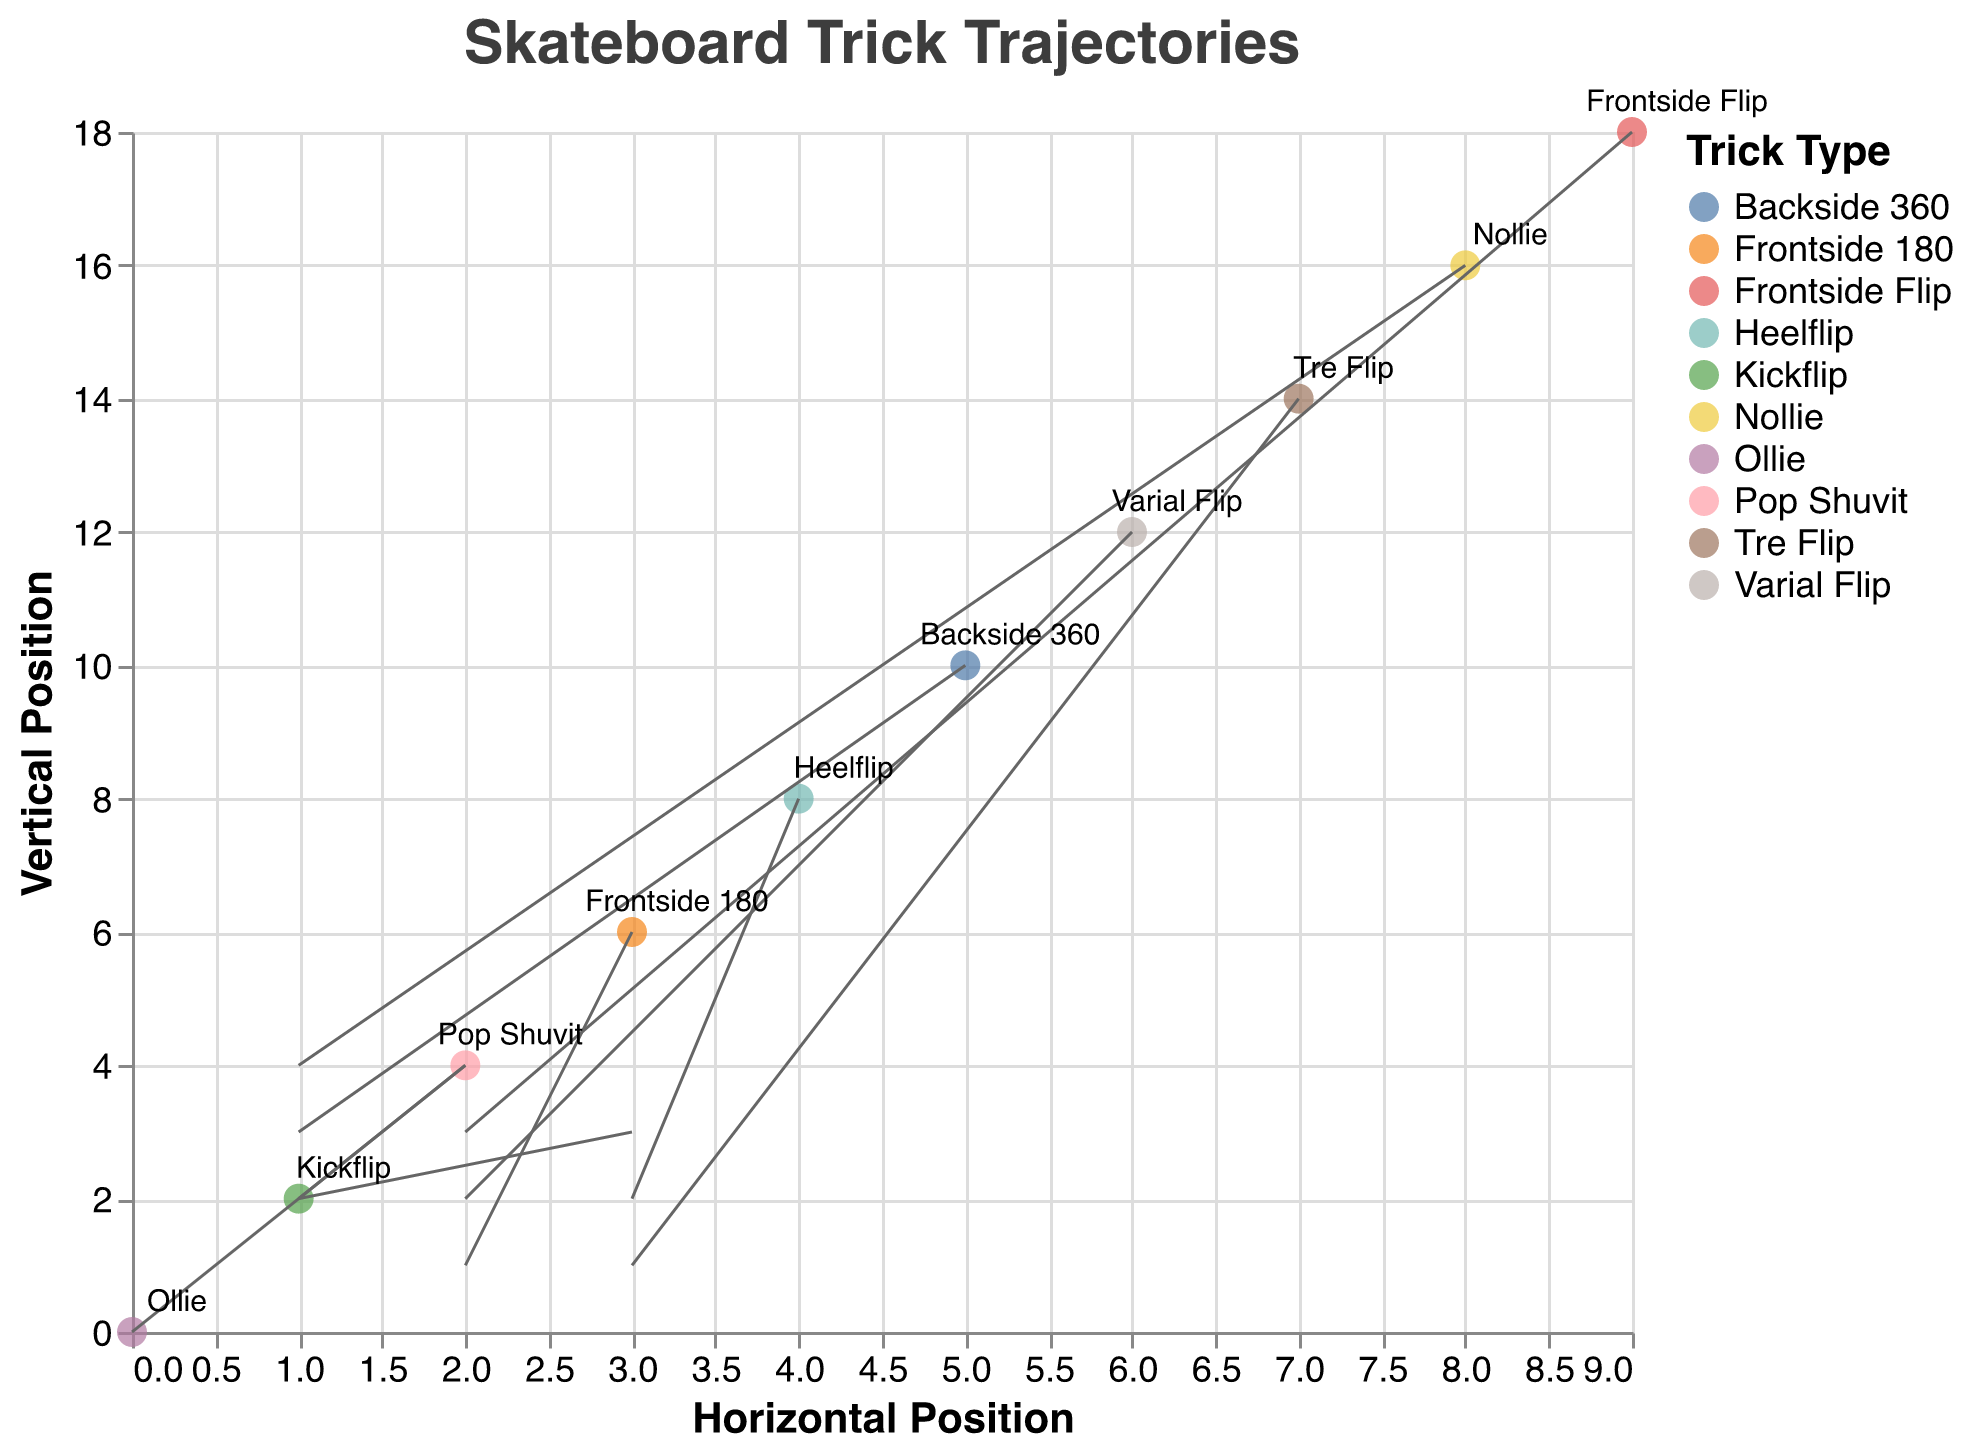What is the title of the figure? The title of the figure is displayed prominently at the top and is typically intended to summarize the theme of the chart. In this case, it reads "Skateboard Trick Trajectories."
Answer: Skateboard Trick Trajectories How many different types of tricks are represented in the quiver plot? By examining the color legend, we see that there are ten distinct trick types listed, one for each color.
Answer: 10 Which trick starts at the highest vertical position? By referring to the y-axis and checking the starting points of each arrow, the highest starting vertical position is 18, which corresponds to the "Frontside Flip" trick.
Answer: Frontside Flip What are the horizontal and vertical start positions of the "Heelflip" trick? By locating "Heelflip" labeled on the plot, we can see it starts at x = 4 and y = 8.
Answer: 4 (horizontal), 8 (vertical) Which trick has the longest vector magnitude? The magnitude of each vector can be calculated using Pythagorean theorem: sqrt(u^2 + v^2). Calculate for each and the greatest magnitude is for "Nollie" with sqrt(1^2 + 4^2) = sqrt(17) ≈ 4.12.
Answer: Nollie What's the average vertical displacement (v) across all tricks? Sum all vertical displacements: 4 + 3 + 2 + 1 + 2 + 3 + 2 + 1 + 4 + 3 = 25. The average is 25/10 = 2.5.
Answer: 2.5 Compare the horizontal displacements (u) of "Kickflip" and "Tre Flip." Which is greater and by how much? "Kickflip" has u = 3, and "Tre Flip" has u = 3. Since 3 - 3 = 0, they are the same.
Answer: Equal, 0 Which trick has the smallest total displacement in both horizontal and vertical directions? Find total displacement for each trick as u + v, the smallest sum is for "Frontside 180" with u + v = 2 + 1 = 3.
Answer: Frontside 180 For the trick "Varial Flip", what are the end coordinates? Using the starting point (6, 12) and the displacements u = 2 and v = 2 for "Varial Flip", the end coordinates are (6 + 2, 12 + 2) = (8, 14).
Answer: (8, 14) Which tricks have an equal horizontal and vertical displacement? By checking each trick where u = v, both "Varial Flip" and "Kickflip" satisfy this condition with u = v = 2 and 3, respectively.
Answer: Varial Flip, Kickflip 